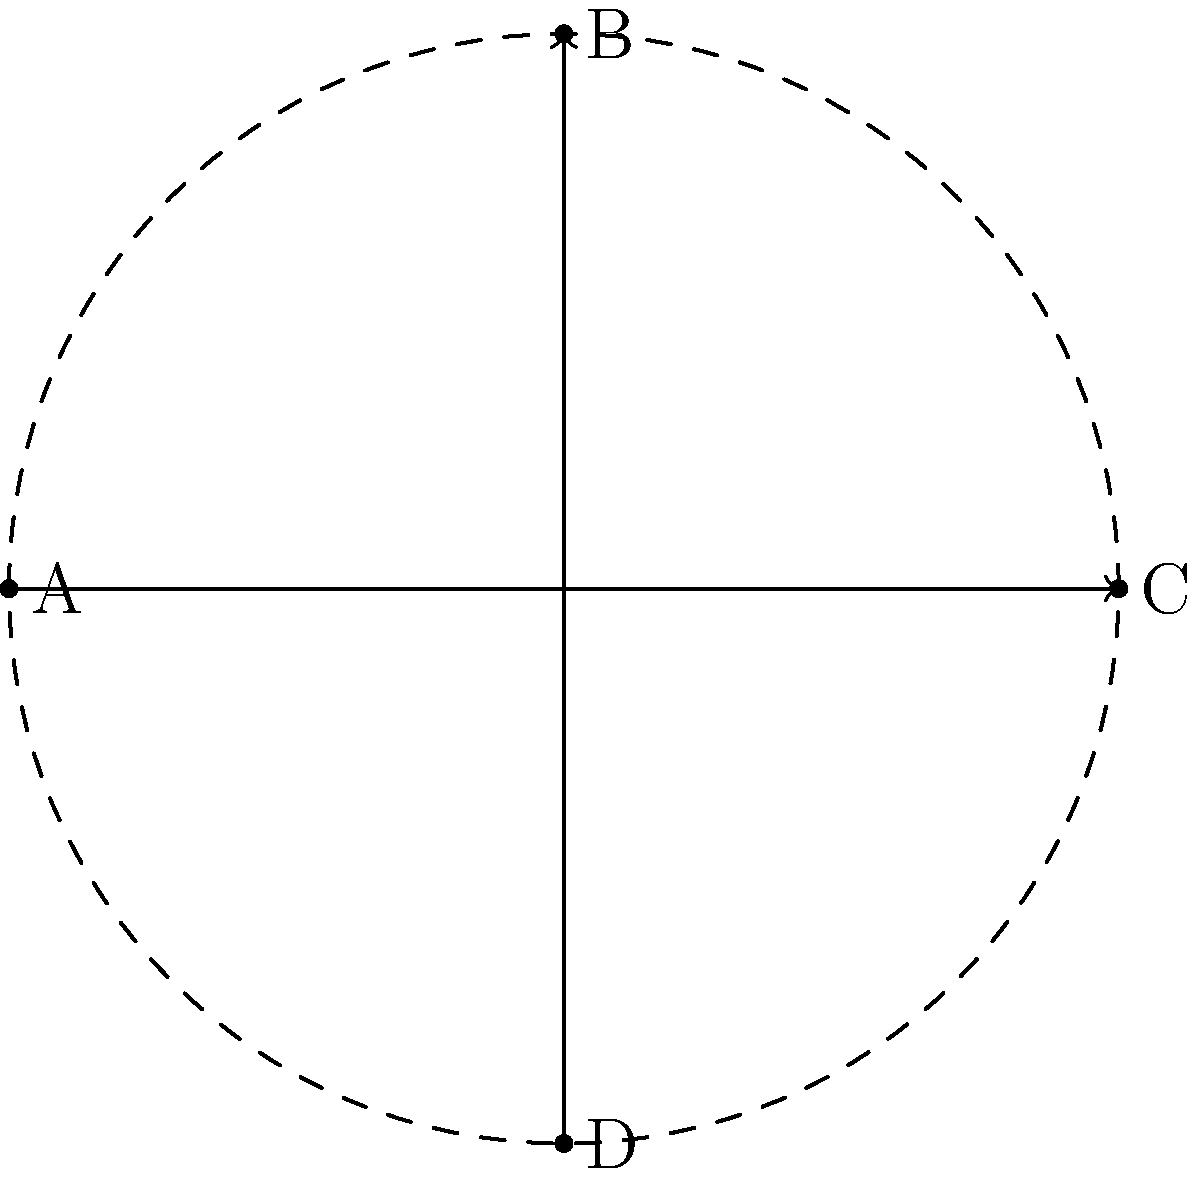Consider the four key positions (A, B, C, D) of a pole vaulter during a jump, as shown in the diagram. These positions form a cyclic group under rotation. If three consecutive 90-degree rotations are applied to position A, what is the resulting position? Express your answer as one of the letters A, B, C, or D. Let's approach this step-by-step:

1) First, we need to understand the order of rotations in this cyclic group:
   A → B → C → D → A (90-degree rotations clockwise)

2) We start at position A and apply three consecutive 90-degree rotations:
   - First rotation: A → B
   - Second rotation: B → C
   - Third rotation: C → D

3) In group theory, this can be expressed as the composition of three group elements:
   $g \circ g \circ g$, where $g$ represents a 90-degree rotation.

4) The result of these three rotations brings us to position D.

5) We can verify this mathematically:
   Let $r$ represent a 90-degree rotation. Then:
   $r^3(A) = r(r(r(A))) = r(r(B)) = r(C) = D$

6) This also demonstrates a property of cyclic groups: $r^4 = e$ (the identity element), as four 90-degree rotations bring us back to the starting position.
Answer: D 